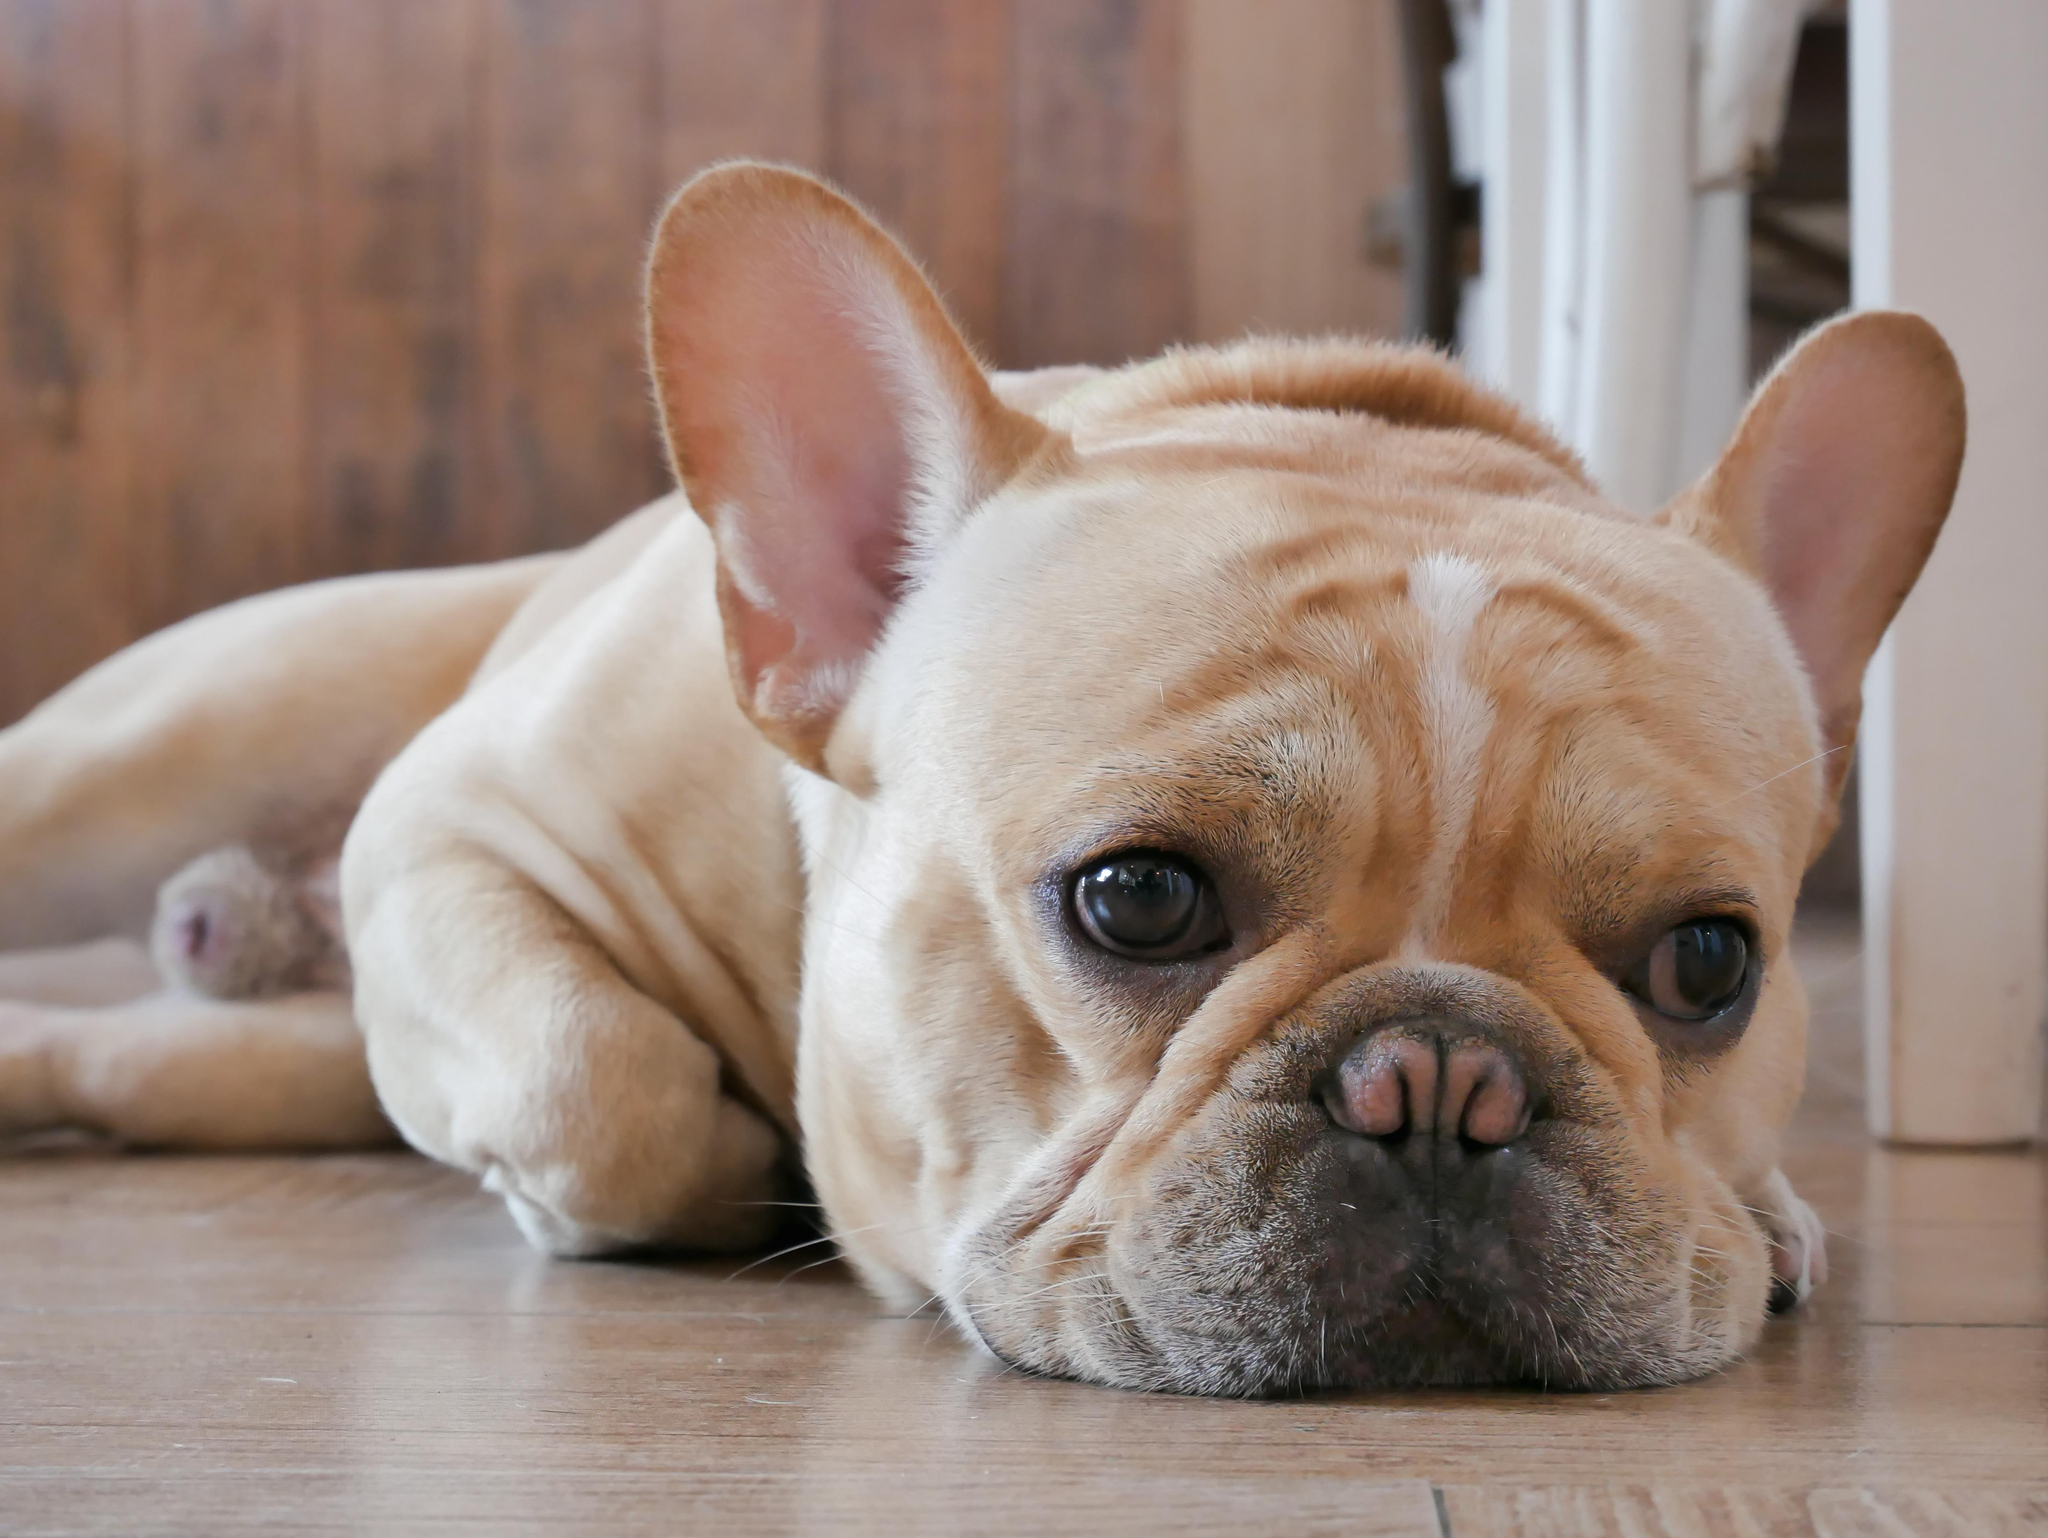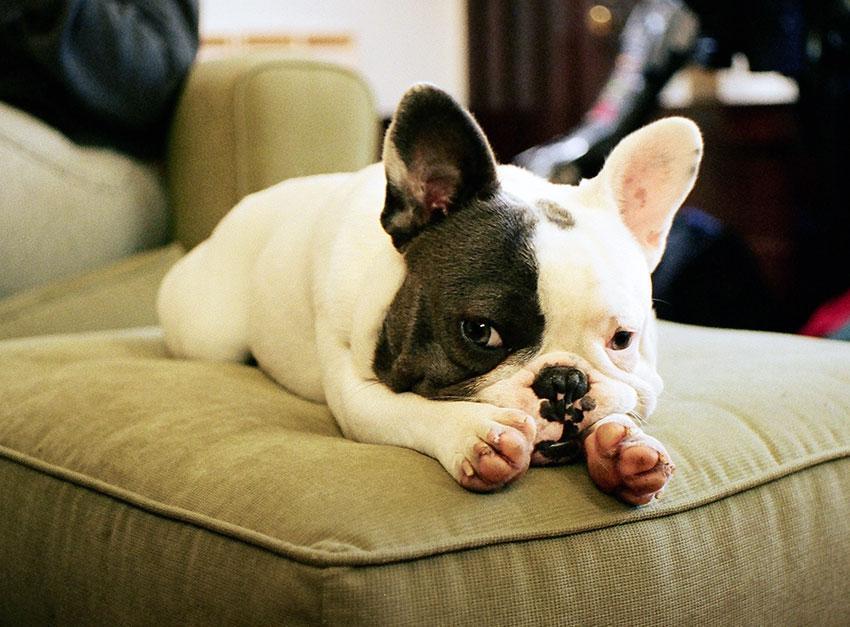The first image is the image on the left, the second image is the image on the right. Given the left and right images, does the statement "There is one dog lying on a wood floor." hold true? Answer yes or no. Yes. The first image is the image on the left, the second image is the image on the right. Evaluate the accuracy of this statement regarding the images: "One of the dogs has its head resting directly on a cushion.". Is it true? Answer yes or no. Yes. 